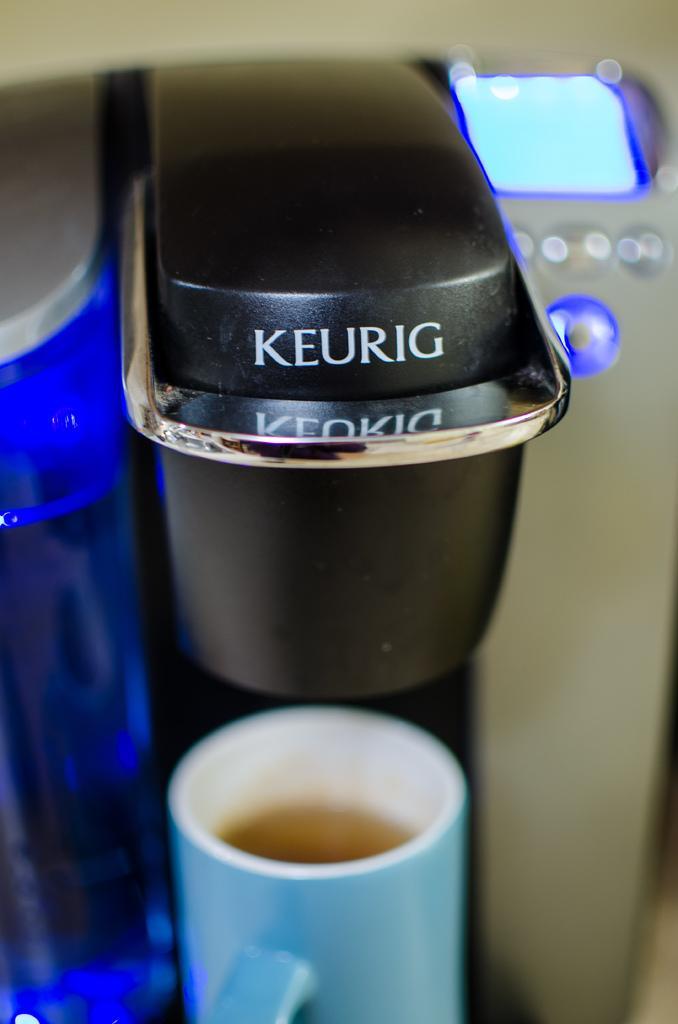How would you summarize this image in a sentence or two? It is a coffee machine there is a coffee cup in blue color, at the bottom. On the right side there is an electronic display in blue color. 